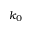Convert formula to latex. <formula><loc_0><loc_0><loc_500><loc_500>k _ { 0 }</formula> 